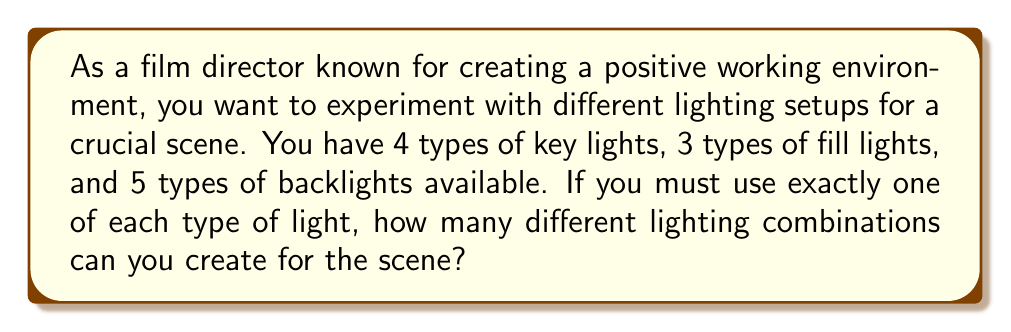Solve this math problem. Let's approach this step-by-step using the multiplication principle of counting:

1) For each lighting combination, we need to choose:
   - One key light out of 4 options
   - One fill light out of 3 options
   - One backlight out of 5 options

2) The choices for each type of light are independent of each other. This means we can use the multiplication principle.

3) According to the multiplication principle, if we have a series of independent choices, the total number of possible outcomes is the product of the number of possibilities for each choice.

4) In this case:
   - There are 4 choices for the key light
   - There are 3 choices for the fill light
   - There are 5 choices for the backlight

5) Therefore, the total number of possible lighting combinations is:

   $$ 4 \times 3 \times 5 = 60 $$

This calculation gives us the total number of ways to select one item from each category when the order of selection doesn't matter (which is the case for our lighting setup).
Answer: 60 different lighting combinations 